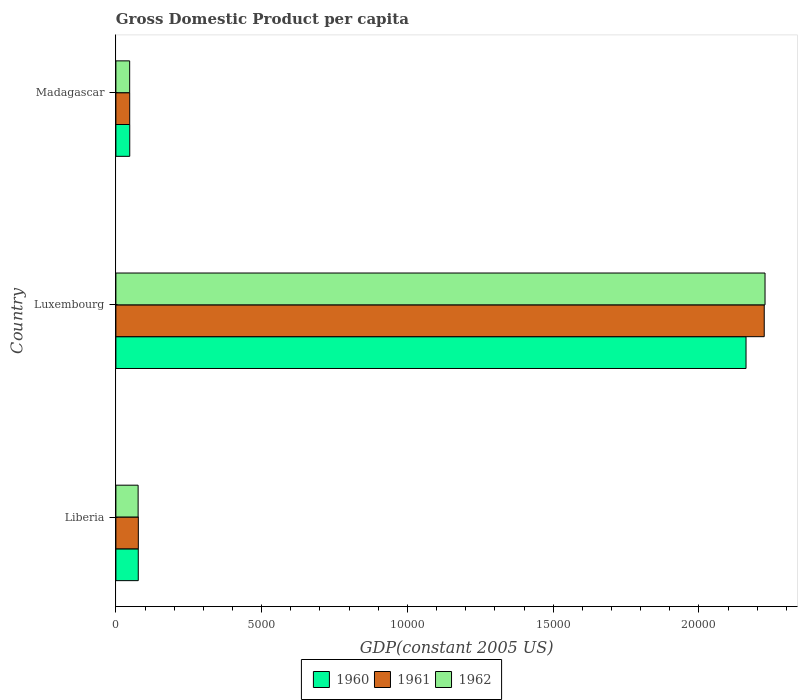How many different coloured bars are there?
Give a very brief answer. 3. Are the number of bars per tick equal to the number of legend labels?
Provide a succinct answer. Yes. Are the number of bars on each tick of the Y-axis equal?
Provide a short and direct response. Yes. How many bars are there on the 3rd tick from the top?
Provide a succinct answer. 3. How many bars are there on the 2nd tick from the bottom?
Your response must be concise. 3. What is the label of the 2nd group of bars from the top?
Offer a terse response. Luxembourg. In how many cases, is the number of bars for a given country not equal to the number of legend labels?
Your answer should be compact. 0. What is the GDP per capita in 1961 in Madagascar?
Keep it short and to the point. 473.7. Across all countries, what is the maximum GDP per capita in 1962?
Offer a very short reply. 2.23e+04. Across all countries, what is the minimum GDP per capita in 1962?
Keep it short and to the point. 472.78. In which country was the GDP per capita in 1962 maximum?
Offer a terse response. Luxembourg. In which country was the GDP per capita in 1962 minimum?
Make the answer very short. Madagascar. What is the total GDP per capita in 1961 in the graph?
Your response must be concise. 2.35e+04. What is the difference between the GDP per capita in 1960 in Luxembourg and that in Madagascar?
Ensure brevity in your answer.  2.11e+04. What is the difference between the GDP per capita in 1962 in Liberia and the GDP per capita in 1960 in Luxembourg?
Give a very brief answer. -2.09e+04. What is the average GDP per capita in 1960 per country?
Give a very brief answer. 7618.89. What is the difference between the GDP per capita in 1960 and GDP per capita in 1961 in Madagascar?
Offer a terse response. 1.8. What is the ratio of the GDP per capita in 1960 in Liberia to that in Luxembourg?
Your response must be concise. 0.04. What is the difference between the highest and the second highest GDP per capita in 1962?
Ensure brevity in your answer.  2.15e+04. What is the difference between the highest and the lowest GDP per capita in 1962?
Your answer should be compact. 2.18e+04. In how many countries, is the GDP per capita in 1961 greater than the average GDP per capita in 1961 taken over all countries?
Your response must be concise. 1. Is the sum of the GDP per capita in 1960 in Liberia and Madagascar greater than the maximum GDP per capita in 1961 across all countries?
Your answer should be very brief. No. What does the 2nd bar from the bottom in Liberia represents?
Your response must be concise. 1961. Is it the case that in every country, the sum of the GDP per capita in 1962 and GDP per capita in 1961 is greater than the GDP per capita in 1960?
Your answer should be compact. Yes. What is the difference between two consecutive major ticks on the X-axis?
Your response must be concise. 5000. Does the graph contain grids?
Offer a very short reply. No. What is the title of the graph?
Offer a very short reply. Gross Domestic Product per capita. What is the label or title of the X-axis?
Your answer should be very brief. GDP(constant 2005 US). What is the GDP(constant 2005 US) in 1960 in Liberia?
Your response must be concise. 767.6. What is the GDP(constant 2005 US) of 1961 in Liberia?
Provide a short and direct response. 769.44. What is the GDP(constant 2005 US) in 1962 in Liberia?
Keep it short and to the point. 762.88. What is the GDP(constant 2005 US) of 1960 in Luxembourg?
Your answer should be compact. 2.16e+04. What is the GDP(constant 2005 US) of 1961 in Luxembourg?
Give a very brief answer. 2.22e+04. What is the GDP(constant 2005 US) of 1962 in Luxembourg?
Offer a terse response. 2.23e+04. What is the GDP(constant 2005 US) in 1960 in Madagascar?
Ensure brevity in your answer.  475.5. What is the GDP(constant 2005 US) in 1961 in Madagascar?
Give a very brief answer. 473.7. What is the GDP(constant 2005 US) in 1962 in Madagascar?
Offer a terse response. 472.78. Across all countries, what is the maximum GDP(constant 2005 US) of 1960?
Make the answer very short. 2.16e+04. Across all countries, what is the maximum GDP(constant 2005 US) in 1961?
Keep it short and to the point. 2.22e+04. Across all countries, what is the maximum GDP(constant 2005 US) of 1962?
Provide a succinct answer. 2.23e+04. Across all countries, what is the minimum GDP(constant 2005 US) in 1960?
Offer a terse response. 475.5. Across all countries, what is the minimum GDP(constant 2005 US) in 1961?
Keep it short and to the point. 473.7. Across all countries, what is the minimum GDP(constant 2005 US) of 1962?
Provide a short and direct response. 472.78. What is the total GDP(constant 2005 US) of 1960 in the graph?
Your answer should be very brief. 2.29e+04. What is the total GDP(constant 2005 US) of 1961 in the graph?
Offer a very short reply. 2.35e+04. What is the total GDP(constant 2005 US) in 1962 in the graph?
Keep it short and to the point. 2.35e+04. What is the difference between the GDP(constant 2005 US) in 1960 in Liberia and that in Luxembourg?
Provide a short and direct response. -2.08e+04. What is the difference between the GDP(constant 2005 US) in 1961 in Liberia and that in Luxembourg?
Your answer should be very brief. -2.15e+04. What is the difference between the GDP(constant 2005 US) of 1962 in Liberia and that in Luxembourg?
Your answer should be very brief. -2.15e+04. What is the difference between the GDP(constant 2005 US) in 1960 in Liberia and that in Madagascar?
Offer a very short reply. 292.1. What is the difference between the GDP(constant 2005 US) of 1961 in Liberia and that in Madagascar?
Provide a short and direct response. 295.74. What is the difference between the GDP(constant 2005 US) in 1962 in Liberia and that in Madagascar?
Make the answer very short. 290.11. What is the difference between the GDP(constant 2005 US) in 1960 in Luxembourg and that in Madagascar?
Your answer should be very brief. 2.11e+04. What is the difference between the GDP(constant 2005 US) in 1961 in Luxembourg and that in Madagascar?
Offer a terse response. 2.18e+04. What is the difference between the GDP(constant 2005 US) of 1962 in Luxembourg and that in Madagascar?
Your answer should be very brief. 2.18e+04. What is the difference between the GDP(constant 2005 US) in 1960 in Liberia and the GDP(constant 2005 US) in 1961 in Luxembourg?
Your answer should be compact. -2.15e+04. What is the difference between the GDP(constant 2005 US) of 1960 in Liberia and the GDP(constant 2005 US) of 1962 in Luxembourg?
Your answer should be compact. -2.15e+04. What is the difference between the GDP(constant 2005 US) in 1961 in Liberia and the GDP(constant 2005 US) in 1962 in Luxembourg?
Provide a short and direct response. -2.15e+04. What is the difference between the GDP(constant 2005 US) of 1960 in Liberia and the GDP(constant 2005 US) of 1961 in Madagascar?
Ensure brevity in your answer.  293.9. What is the difference between the GDP(constant 2005 US) of 1960 in Liberia and the GDP(constant 2005 US) of 1962 in Madagascar?
Offer a very short reply. 294.82. What is the difference between the GDP(constant 2005 US) of 1961 in Liberia and the GDP(constant 2005 US) of 1962 in Madagascar?
Provide a succinct answer. 296.67. What is the difference between the GDP(constant 2005 US) of 1960 in Luxembourg and the GDP(constant 2005 US) of 1961 in Madagascar?
Give a very brief answer. 2.11e+04. What is the difference between the GDP(constant 2005 US) in 1960 in Luxembourg and the GDP(constant 2005 US) in 1962 in Madagascar?
Offer a terse response. 2.11e+04. What is the difference between the GDP(constant 2005 US) of 1961 in Luxembourg and the GDP(constant 2005 US) of 1962 in Madagascar?
Provide a short and direct response. 2.18e+04. What is the average GDP(constant 2005 US) in 1960 per country?
Give a very brief answer. 7618.89. What is the average GDP(constant 2005 US) in 1961 per country?
Your answer should be very brief. 7826.96. What is the average GDP(constant 2005 US) in 1962 per country?
Make the answer very short. 7833.71. What is the difference between the GDP(constant 2005 US) of 1960 and GDP(constant 2005 US) of 1961 in Liberia?
Offer a terse response. -1.85. What is the difference between the GDP(constant 2005 US) in 1960 and GDP(constant 2005 US) in 1962 in Liberia?
Your answer should be very brief. 4.71. What is the difference between the GDP(constant 2005 US) of 1961 and GDP(constant 2005 US) of 1962 in Liberia?
Offer a very short reply. 6.56. What is the difference between the GDP(constant 2005 US) in 1960 and GDP(constant 2005 US) in 1961 in Luxembourg?
Your answer should be very brief. -624.17. What is the difference between the GDP(constant 2005 US) in 1960 and GDP(constant 2005 US) in 1962 in Luxembourg?
Your answer should be very brief. -651.89. What is the difference between the GDP(constant 2005 US) in 1961 and GDP(constant 2005 US) in 1962 in Luxembourg?
Offer a terse response. -27.73. What is the difference between the GDP(constant 2005 US) of 1960 and GDP(constant 2005 US) of 1961 in Madagascar?
Provide a short and direct response. 1.8. What is the difference between the GDP(constant 2005 US) in 1960 and GDP(constant 2005 US) in 1962 in Madagascar?
Make the answer very short. 2.72. What is the difference between the GDP(constant 2005 US) of 1961 and GDP(constant 2005 US) of 1962 in Madagascar?
Your answer should be compact. 0.92. What is the ratio of the GDP(constant 2005 US) in 1960 in Liberia to that in Luxembourg?
Give a very brief answer. 0.04. What is the ratio of the GDP(constant 2005 US) in 1961 in Liberia to that in Luxembourg?
Offer a terse response. 0.03. What is the ratio of the GDP(constant 2005 US) in 1962 in Liberia to that in Luxembourg?
Give a very brief answer. 0.03. What is the ratio of the GDP(constant 2005 US) of 1960 in Liberia to that in Madagascar?
Give a very brief answer. 1.61. What is the ratio of the GDP(constant 2005 US) in 1961 in Liberia to that in Madagascar?
Offer a very short reply. 1.62. What is the ratio of the GDP(constant 2005 US) in 1962 in Liberia to that in Madagascar?
Ensure brevity in your answer.  1.61. What is the ratio of the GDP(constant 2005 US) of 1960 in Luxembourg to that in Madagascar?
Give a very brief answer. 45.45. What is the ratio of the GDP(constant 2005 US) of 1961 in Luxembourg to that in Madagascar?
Keep it short and to the point. 46.95. What is the ratio of the GDP(constant 2005 US) in 1962 in Luxembourg to that in Madagascar?
Offer a terse response. 47.1. What is the difference between the highest and the second highest GDP(constant 2005 US) in 1960?
Provide a short and direct response. 2.08e+04. What is the difference between the highest and the second highest GDP(constant 2005 US) in 1961?
Your response must be concise. 2.15e+04. What is the difference between the highest and the second highest GDP(constant 2005 US) in 1962?
Your answer should be very brief. 2.15e+04. What is the difference between the highest and the lowest GDP(constant 2005 US) of 1960?
Give a very brief answer. 2.11e+04. What is the difference between the highest and the lowest GDP(constant 2005 US) of 1961?
Provide a short and direct response. 2.18e+04. What is the difference between the highest and the lowest GDP(constant 2005 US) of 1962?
Ensure brevity in your answer.  2.18e+04. 